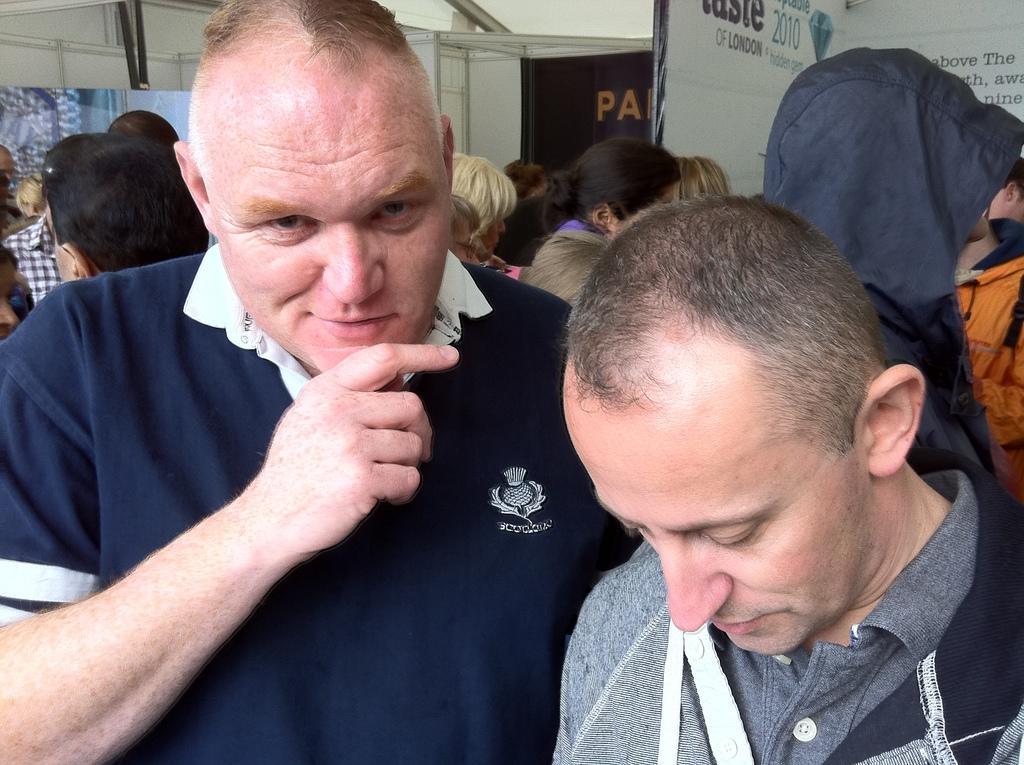Can you describe this image briefly? In this image, we can see a group of people. In the background, we can see hoardings, on the hoardings, we can see some pictures and some text written on it and the white color wall. 